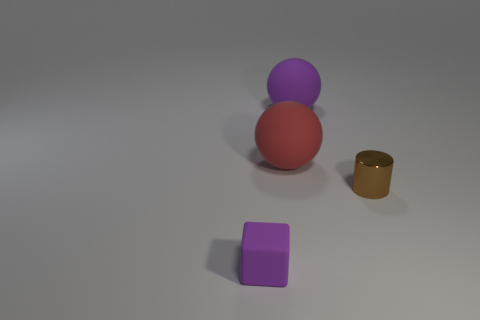Are there more matte things that are in front of the big purple object than small blocks that are behind the brown metal cylinder?
Offer a very short reply. Yes. Are there any large cyan metal things?
Your answer should be compact. No. There is a object that is the same color as the matte cube; what material is it?
Give a very brief answer. Rubber. How many things are either big brown matte cylinders or cubes?
Keep it short and to the point. 1. Is there a ball of the same color as the cube?
Ensure brevity in your answer.  Yes. What number of large purple rubber spheres are on the right side of the ball on the left side of the big purple rubber thing?
Provide a short and direct response. 1. Is the number of brown shiny cylinders greater than the number of tiny objects?
Offer a very short reply. No. Is the cylinder made of the same material as the tiny purple cube?
Offer a very short reply. No. Are there an equal number of purple rubber objects that are behind the cube and objects?
Keep it short and to the point. No. What number of small brown cylinders are made of the same material as the cube?
Provide a succinct answer. 0. 